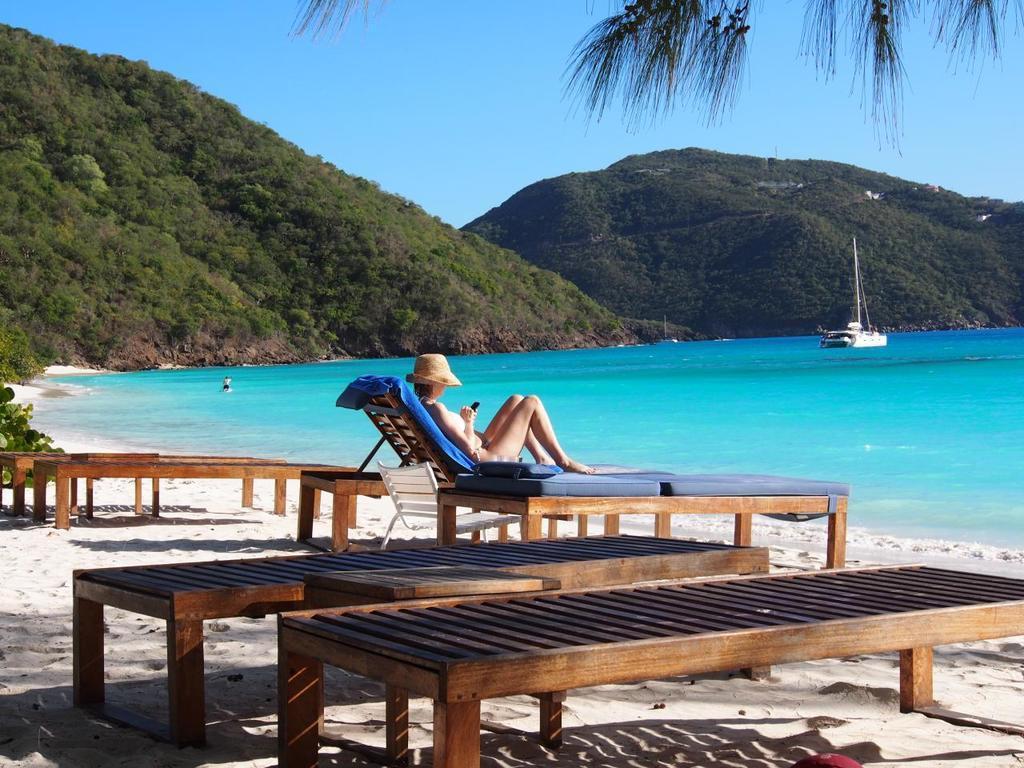Describe this image in one or two sentences. Here we can see a woman lying on a chair near a beach and we can see a boat in the water and we can see mountains and the sky is clear 